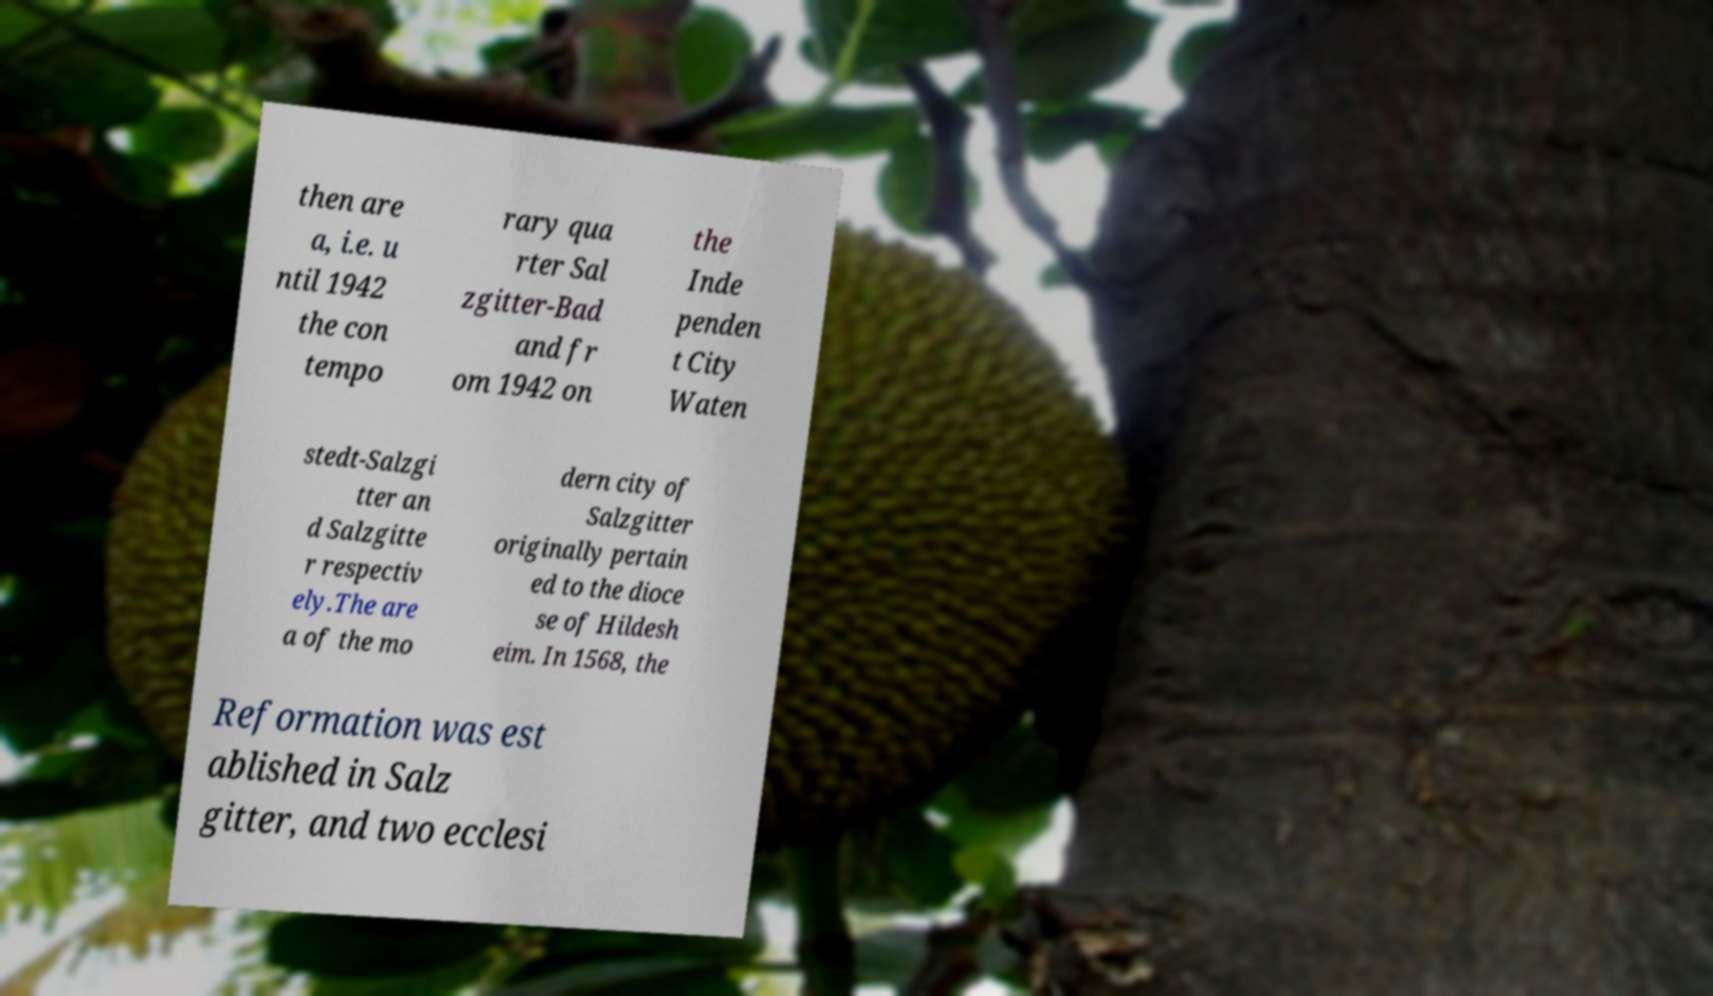Can you accurately transcribe the text from the provided image for me? then are a, i.e. u ntil 1942 the con tempo rary qua rter Sal zgitter-Bad and fr om 1942 on the Inde penden t City Waten stedt-Salzgi tter an d Salzgitte r respectiv ely.The are a of the mo dern city of Salzgitter originally pertain ed to the dioce se of Hildesh eim. In 1568, the Reformation was est ablished in Salz gitter, and two ecclesi 